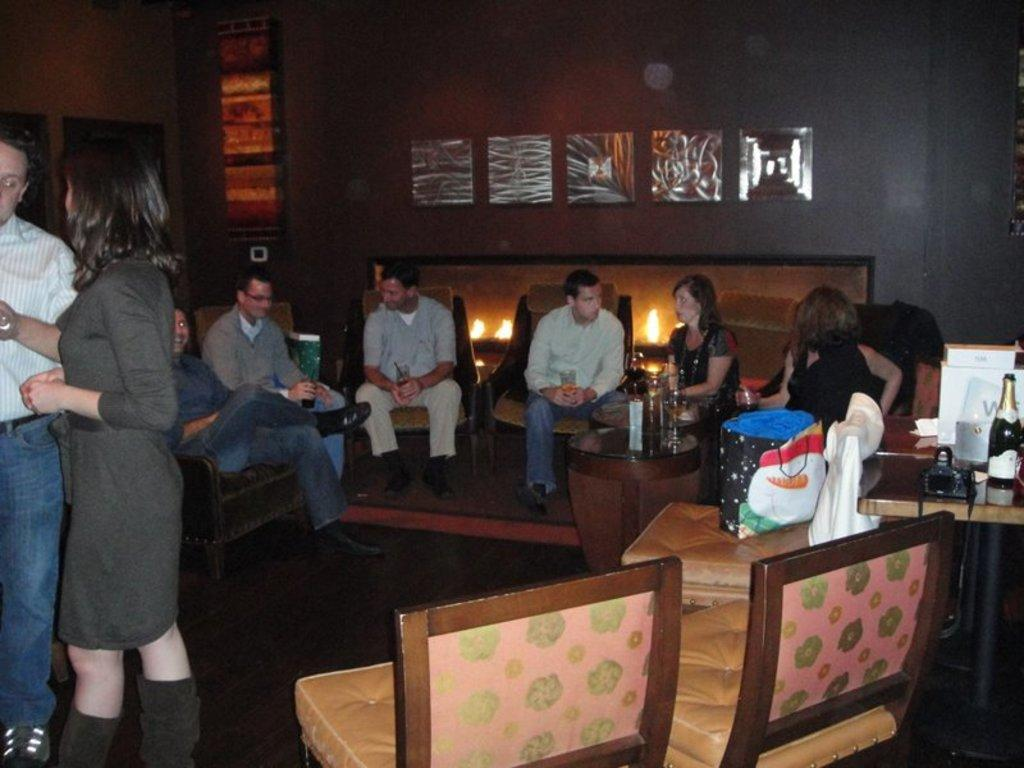What are the people in the image doing? There is a group of people sitting in chairs, and they are talking to each other. Are there any other people in the image besides the group sitting in chairs? Yes, there is a couple standing aside. What type of knot is the couple using to secure their leather trail in the image? There is no knot, leather, or trail present in the image. 